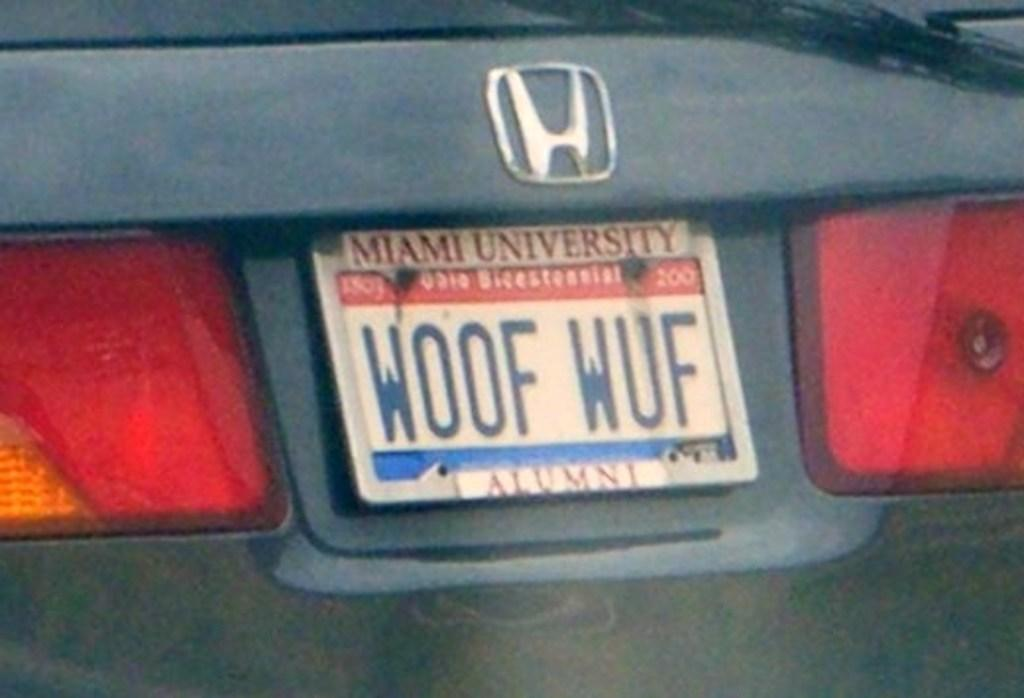<image>
Describe the image concisely. The licence plate on the Honda is celebrating Ohio Bicentennial. 